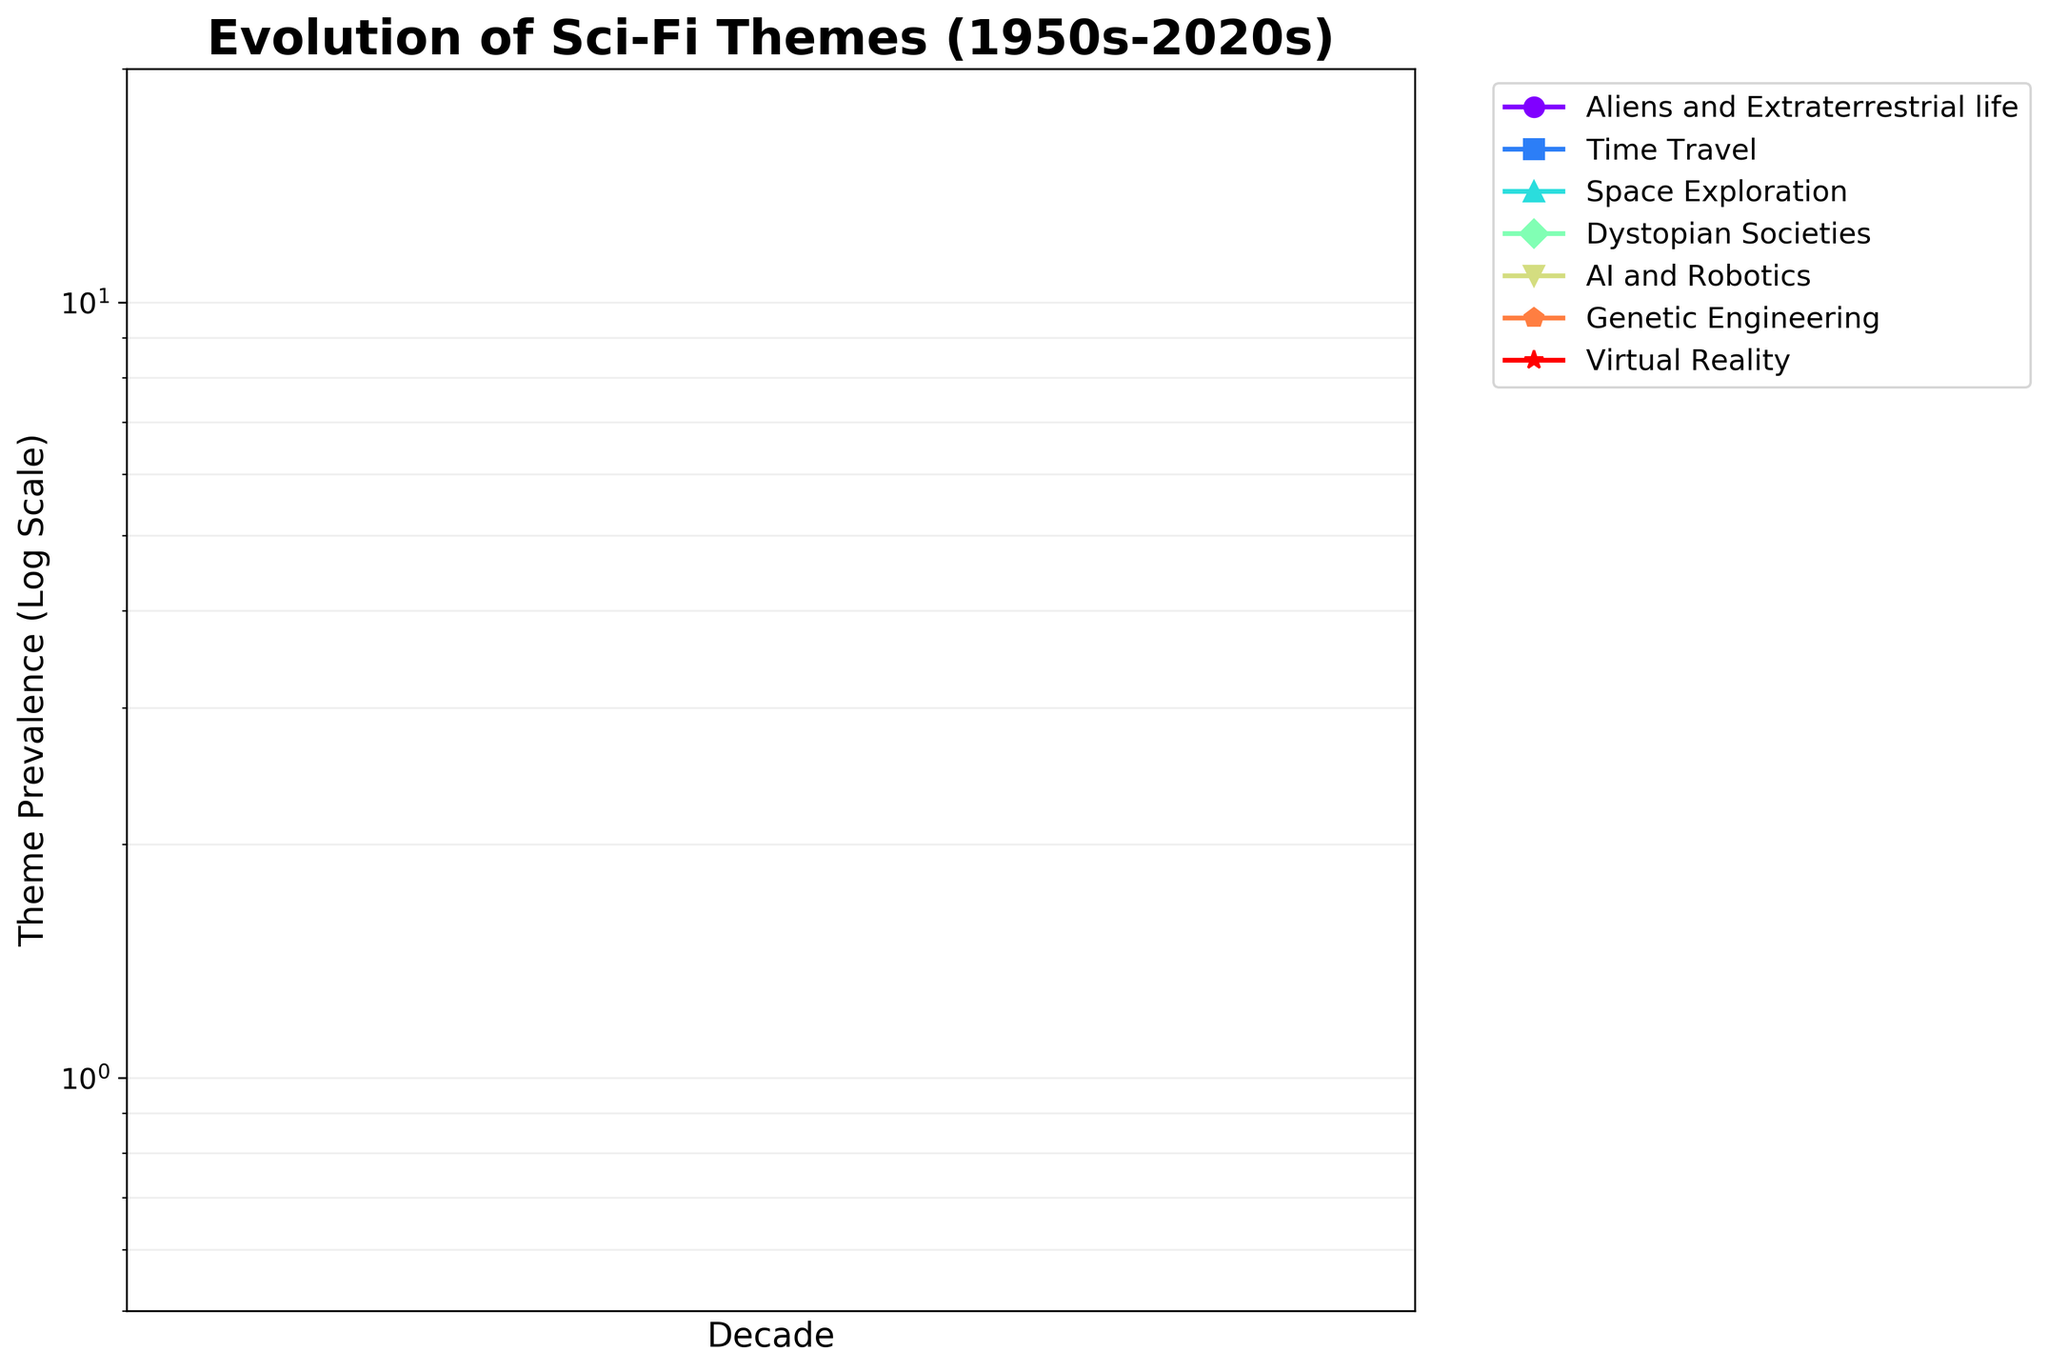What is the title of the plot? The title is prominently displayed at the top of the plot, providing an overview of what the plot is about. The title reads "Evolution of Sci-Fi Themes (1950s-2020s)."
Answer: "Evolution of Sci-Fi Themes (1950s-2020s)" What is the theme with the highest prevalence in the 2020s? By looking at the data points in the 2020s, we can identify which theme has the highest value on the y-axis. The theme "AI and Robotics" has the highest prevalence.
Answer: "AI and Robotics" Which theme had a constant increase in prevalence every decade from the 1950s to the 2020s? To determine this, we need to track the data points for each theme across all decades and see if there is a consistent upward trend. "AI and Robotics" shows a constant increase each decade.
Answer: "AI and Robotics" How does the prevalence of Time Travel in the 1970s compare to that in the 2010s? We need to find the data points for Time Travel in both the 1970s and 2010s. It is 5 in the 1970s and 10 in the 2010s. The prevalence in the 2010s is double that of the 1970s.
Answer: The 2010s have double the prevalence than the 1970s What is the general trend for the theme "Space Exploration" from the 1950s to the 2020s? By examining the data points for Space Exploration across all decades, we observe a general downward trend. The values start from 7 in the 1950s and drop to 4 in the 2020s.
Answer: Downward trend In which decade did the theme "Dystopian Societies" see the highest rise compared to the previous decade? We compare the data points for each decade, calculating the differences from the previous decade. The sharpest rise for "Dystopian Societies" happened between the 1970s (5) and 1980s (6).
Answer: The 1970s to 1980s What is the relative change in prevalence of "Genetic Engineering" from the 1990s to the 2020s? The prevalence of Genetic Engineering in the 1990s was 5 and increased to 9 in the 2020s. The relative change can be calculated as ((9-5)/5) * 100%. This gives us an 80% increase.
Answer: 80% increase How many unique themes are shown in the plot? The legend on the plot lists all the themes represented by different lines with colors and markers. Counting these, we find there are seven unique themes.
Answer: Seven Which theme had a decrease in prevalence from the 1990s to the 2000s? By analyzing the values for each theme across these two decades, we see that "Space Exploration" decreased from 7 in the 1990s to 6 in the 2000s.
Answer: Space Exploration What is the x-axis label of the plot? The x-axis label is typically found along the horizontal axis of the plot. In this case, it reads "Decade."
Answer: Decade 